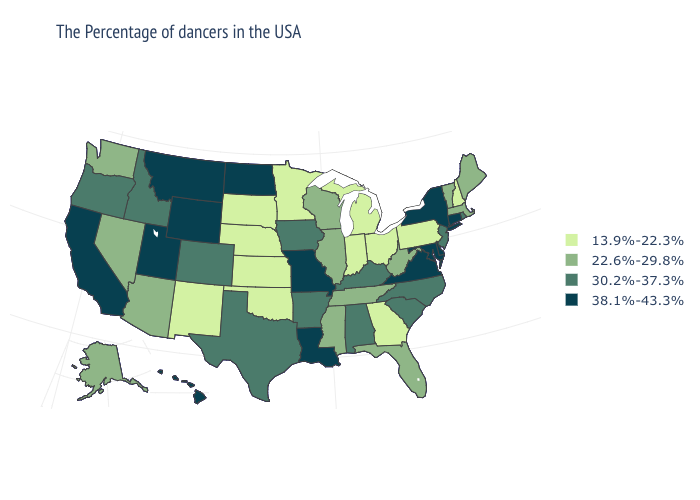What is the highest value in the West ?
Concise answer only. 38.1%-43.3%. Name the states that have a value in the range 30.2%-37.3%?
Keep it brief. Rhode Island, New Jersey, North Carolina, South Carolina, Kentucky, Alabama, Arkansas, Iowa, Texas, Colorado, Idaho, Oregon. Among the states that border Illinois , does Wisconsin have the lowest value?
Concise answer only. No. What is the lowest value in states that border Alabama?
Quick response, please. 13.9%-22.3%. Name the states that have a value in the range 22.6%-29.8%?
Quick response, please. Maine, Massachusetts, Vermont, West Virginia, Florida, Tennessee, Wisconsin, Illinois, Mississippi, Arizona, Nevada, Washington, Alaska. Among the states that border Louisiana , does Texas have the lowest value?
Quick response, please. No. Does Kansas have the lowest value in the USA?
Keep it brief. Yes. Name the states that have a value in the range 13.9%-22.3%?
Be succinct. New Hampshire, Pennsylvania, Ohio, Georgia, Michigan, Indiana, Minnesota, Kansas, Nebraska, Oklahoma, South Dakota, New Mexico. Does Arizona have a lower value than New Hampshire?
Be succinct. No. Does the map have missing data?
Concise answer only. No. What is the value of Vermont?
Quick response, please. 22.6%-29.8%. Among the states that border Texas , which have the highest value?
Give a very brief answer. Louisiana. How many symbols are there in the legend?
Short answer required. 4. Does Arkansas have the same value as Wyoming?
Write a very short answer. No. Which states have the highest value in the USA?
Keep it brief. Connecticut, New York, Delaware, Maryland, Virginia, Louisiana, Missouri, North Dakota, Wyoming, Utah, Montana, California, Hawaii. 